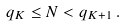Convert formula to latex. <formula><loc_0><loc_0><loc_500><loc_500>q _ { K } \leq N < q _ { K + 1 } \, .</formula> 